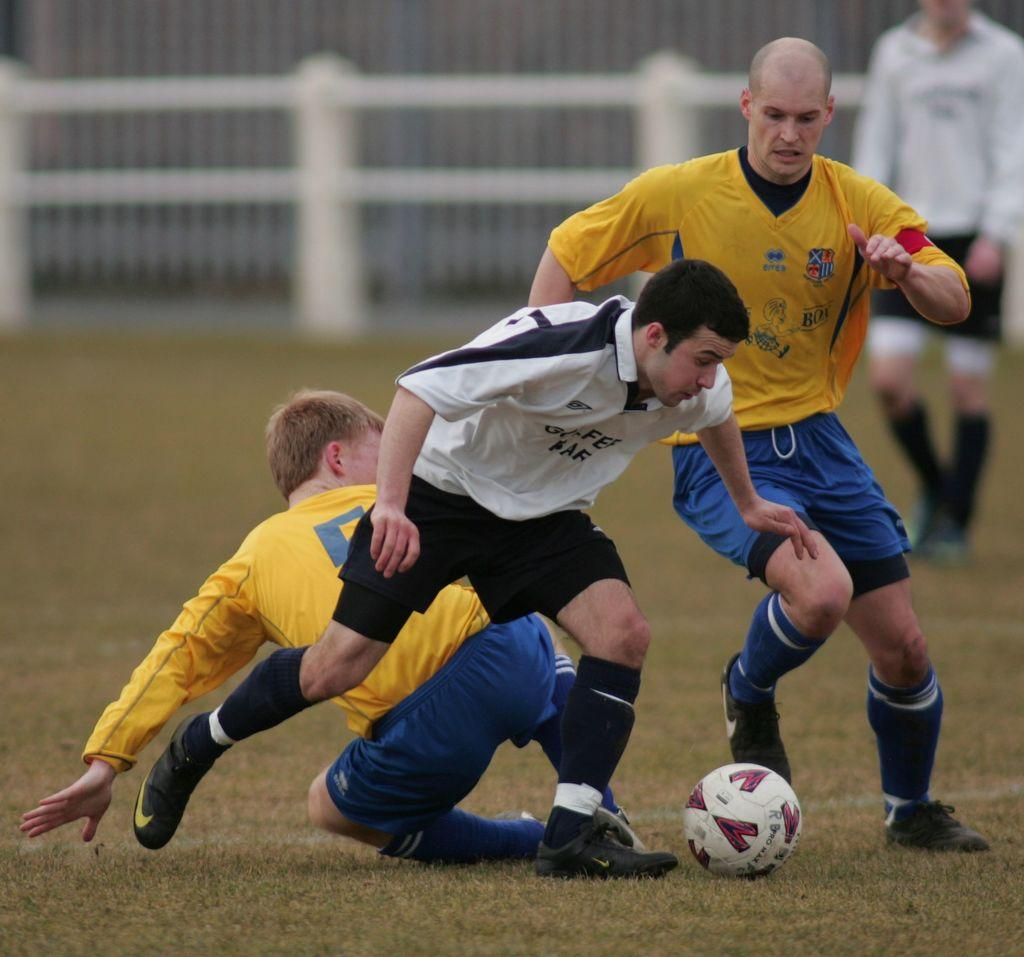How many people are in the image? There is a group of people in the image, but the exact number is not specified. What are the people doing in the image? The people are on the ground, which suggests they might be sitting, lying down, or playing. What type of surface can be seen in the image? There is grass visible in the image, indicating that the scene is outdoors. What object is on the ground with the people? There is a ball on the ground in the image. What can be seen in the background of the image? There is a fence in the background of the image. What is the tendency of the rod to break records in the image? There is no rod present in the image, so it is not possible to determine its tendency or ability to break records. 